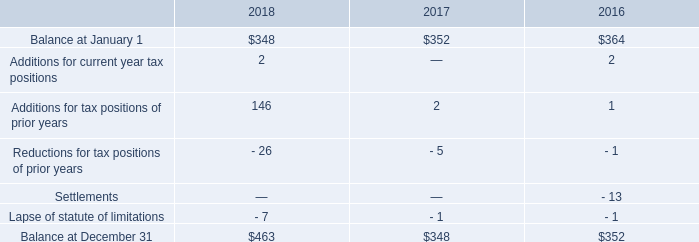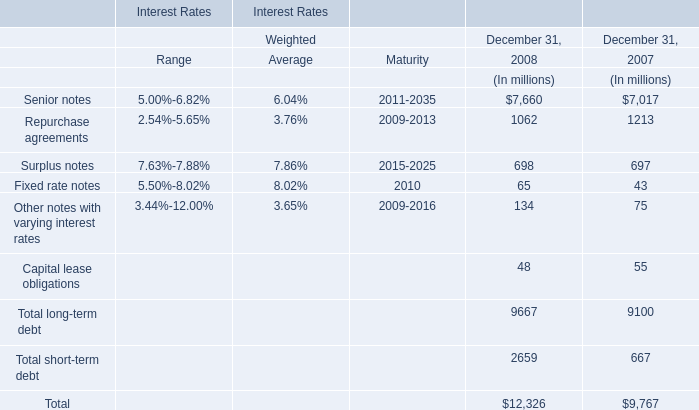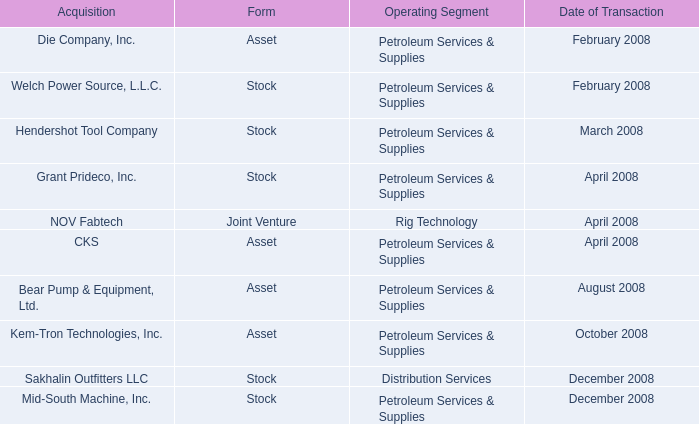What is the value of the Total long-term debt in the year where Total short-term debt is greater than 2000 million? (in million) 
Answer: 9667. 